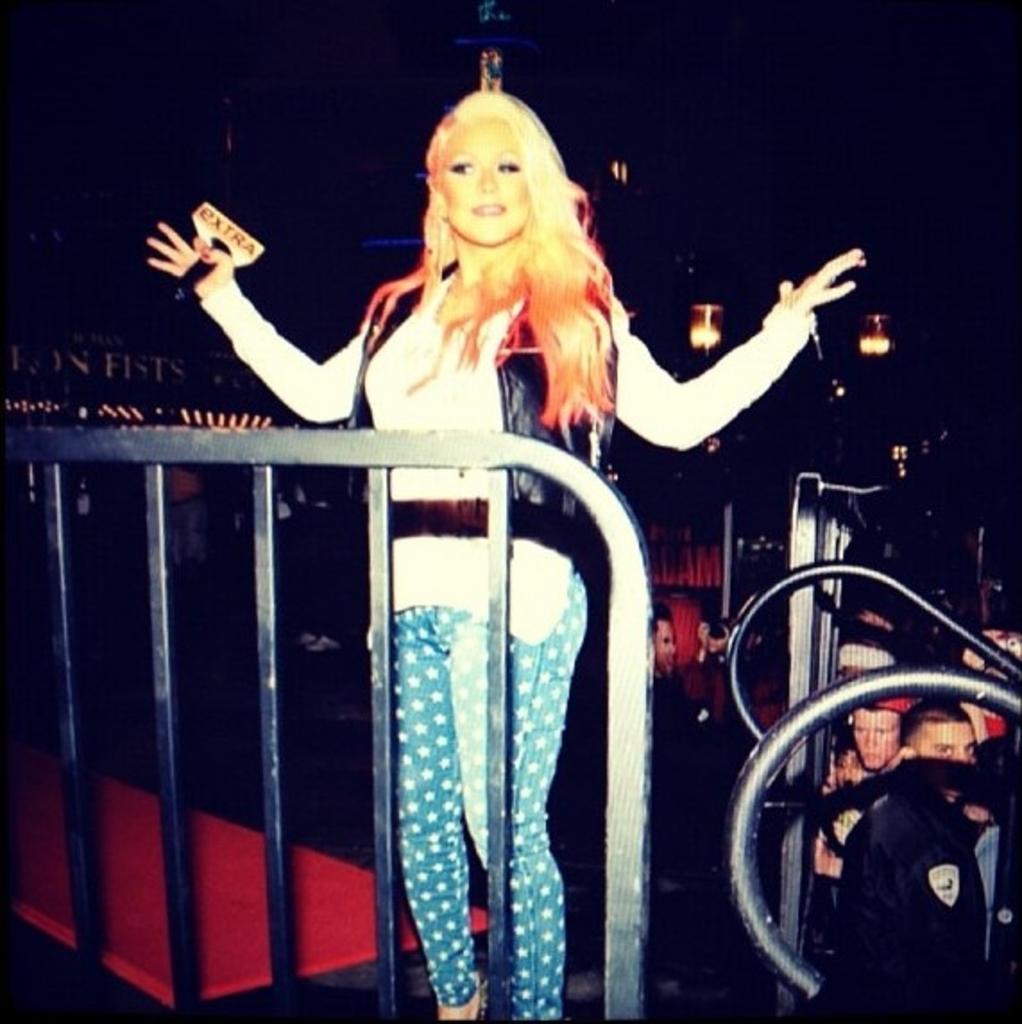Can you describe this image briefly? In the middle of this image, there is a person in a white color T-shirt, holding a microphone with a hand, smiling and standing in front of a fence. In the background, there are other persons, there are lights and a hoarding arranged and there are other objects. And the background is dark in color. 